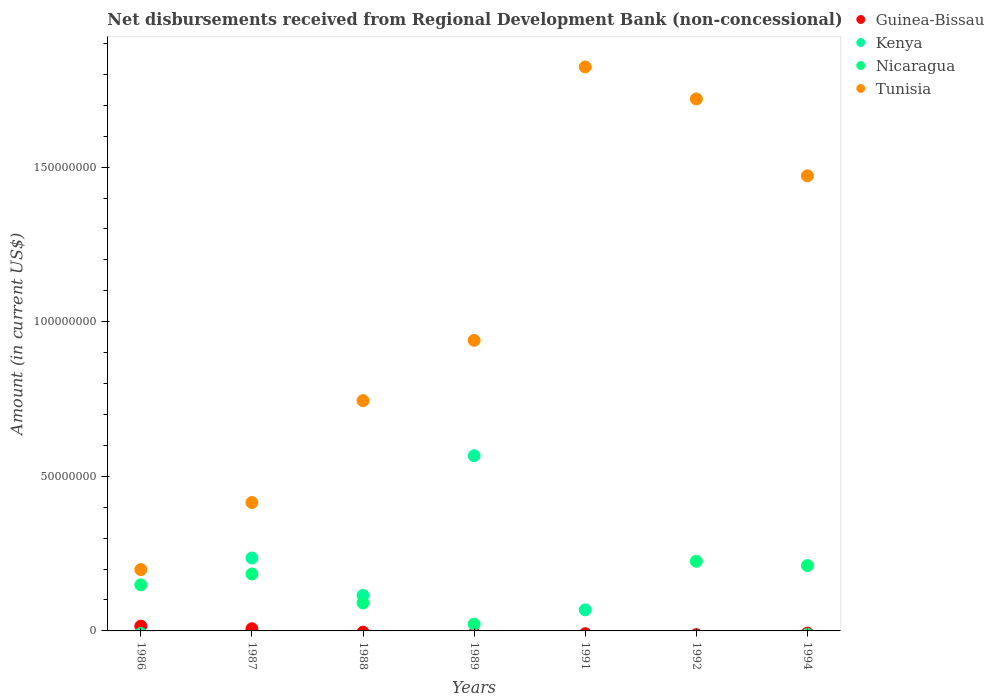What is the amount of disbursements received from Regional Development Bank in Kenya in 1992?
Provide a succinct answer. 0. Across all years, what is the maximum amount of disbursements received from Regional Development Bank in Nicaragua?
Keep it short and to the point. 2.25e+07. In which year was the amount of disbursements received from Regional Development Bank in Guinea-Bissau maximum?
Give a very brief answer. 1986. What is the total amount of disbursements received from Regional Development Bank in Kenya in the graph?
Ensure brevity in your answer.  9.85e+07. What is the difference between the amount of disbursements received from Regional Development Bank in Tunisia in 1989 and that in 1992?
Keep it short and to the point. -7.81e+07. What is the difference between the amount of disbursements received from Regional Development Bank in Guinea-Bissau in 1991 and the amount of disbursements received from Regional Development Bank in Nicaragua in 1992?
Your answer should be compact. -2.25e+07. What is the average amount of disbursements received from Regional Development Bank in Tunisia per year?
Your response must be concise. 1.04e+08. In the year 1987, what is the difference between the amount of disbursements received from Regional Development Bank in Tunisia and amount of disbursements received from Regional Development Bank in Nicaragua?
Your answer should be compact. 2.31e+07. What is the ratio of the amount of disbursements received from Regional Development Bank in Nicaragua in 1989 to that in 1992?
Make the answer very short. 0.1. Is the amount of disbursements received from Regional Development Bank in Tunisia in 1986 less than that in 1992?
Give a very brief answer. Yes. Is the difference between the amount of disbursements received from Regional Development Bank in Tunisia in 1986 and 1989 greater than the difference between the amount of disbursements received from Regional Development Bank in Nicaragua in 1986 and 1989?
Give a very brief answer. No. What is the difference between the highest and the second highest amount of disbursements received from Regional Development Bank in Kenya?
Your answer should be very brief. 3.31e+07. What is the difference between the highest and the lowest amount of disbursements received from Regional Development Bank in Nicaragua?
Offer a very short reply. 2.25e+07. In how many years, is the amount of disbursements received from Regional Development Bank in Tunisia greater than the average amount of disbursements received from Regional Development Bank in Tunisia taken over all years?
Keep it short and to the point. 3. Is the sum of the amount of disbursements received from Regional Development Bank in Tunisia in 1991 and 1992 greater than the maximum amount of disbursements received from Regional Development Bank in Guinea-Bissau across all years?
Give a very brief answer. Yes. Is it the case that in every year, the sum of the amount of disbursements received from Regional Development Bank in Guinea-Bissau and amount of disbursements received from Regional Development Bank in Nicaragua  is greater than the sum of amount of disbursements received from Regional Development Bank in Kenya and amount of disbursements received from Regional Development Bank in Tunisia?
Ensure brevity in your answer.  No. Is the amount of disbursements received from Regional Development Bank in Kenya strictly greater than the amount of disbursements received from Regional Development Bank in Guinea-Bissau over the years?
Offer a terse response. No. Is the amount of disbursements received from Regional Development Bank in Nicaragua strictly less than the amount of disbursements received from Regional Development Bank in Guinea-Bissau over the years?
Provide a short and direct response. No. What is the difference between two consecutive major ticks on the Y-axis?
Your answer should be very brief. 5.00e+07. Are the values on the major ticks of Y-axis written in scientific E-notation?
Make the answer very short. No. Does the graph contain any zero values?
Your answer should be compact. Yes. Does the graph contain grids?
Your response must be concise. No. What is the title of the graph?
Keep it short and to the point. Net disbursements received from Regional Development Bank (non-concessional). What is the label or title of the X-axis?
Give a very brief answer. Years. What is the Amount (in current US$) of Guinea-Bissau in 1986?
Provide a succinct answer. 1.56e+06. What is the Amount (in current US$) in Nicaragua in 1986?
Keep it short and to the point. 1.49e+07. What is the Amount (in current US$) of Tunisia in 1986?
Make the answer very short. 1.98e+07. What is the Amount (in current US$) in Guinea-Bissau in 1987?
Your answer should be compact. 7.05e+05. What is the Amount (in current US$) of Kenya in 1987?
Your answer should be compact. 2.36e+07. What is the Amount (in current US$) of Nicaragua in 1987?
Your response must be concise. 1.84e+07. What is the Amount (in current US$) in Tunisia in 1987?
Give a very brief answer. 4.15e+07. What is the Amount (in current US$) in Guinea-Bissau in 1988?
Offer a very short reply. 0. What is the Amount (in current US$) in Kenya in 1988?
Your answer should be very brief. 1.15e+07. What is the Amount (in current US$) in Nicaragua in 1988?
Offer a very short reply. 9.03e+06. What is the Amount (in current US$) of Tunisia in 1988?
Provide a succinct answer. 7.45e+07. What is the Amount (in current US$) of Guinea-Bissau in 1989?
Your answer should be compact. 0. What is the Amount (in current US$) in Kenya in 1989?
Your answer should be compact. 5.67e+07. What is the Amount (in current US$) of Nicaragua in 1989?
Make the answer very short. 2.19e+06. What is the Amount (in current US$) in Tunisia in 1989?
Ensure brevity in your answer.  9.40e+07. What is the Amount (in current US$) in Kenya in 1991?
Your answer should be very brief. 6.82e+06. What is the Amount (in current US$) of Tunisia in 1991?
Your answer should be very brief. 1.82e+08. What is the Amount (in current US$) of Guinea-Bissau in 1992?
Provide a succinct answer. 0. What is the Amount (in current US$) of Kenya in 1992?
Ensure brevity in your answer.  0. What is the Amount (in current US$) of Nicaragua in 1992?
Your response must be concise. 2.25e+07. What is the Amount (in current US$) of Tunisia in 1992?
Your answer should be compact. 1.72e+08. What is the Amount (in current US$) in Guinea-Bissau in 1994?
Your answer should be compact. 0. What is the Amount (in current US$) in Kenya in 1994?
Ensure brevity in your answer.  0. What is the Amount (in current US$) in Nicaragua in 1994?
Your response must be concise. 2.11e+07. What is the Amount (in current US$) in Tunisia in 1994?
Offer a terse response. 1.47e+08. Across all years, what is the maximum Amount (in current US$) in Guinea-Bissau?
Your response must be concise. 1.56e+06. Across all years, what is the maximum Amount (in current US$) in Kenya?
Your answer should be compact. 5.67e+07. Across all years, what is the maximum Amount (in current US$) in Nicaragua?
Keep it short and to the point. 2.25e+07. Across all years, what is the maximum Amount (in current US$) of Tunisia?
Your response must be concise. 1.82e+08. Across all years, what is the minimum Amount (in current US$) in Guinea-Bissau?
Give a very brief answer. 0. Across all years, what is the minimum Amount (in current US$) in Tunisia?
Your response must be concise. 1.98e+07. What is the total Amount (in current US$) in Guinea-Bissau in the graph?
Provide a succinct answer. 2.27e+06. What is the total Amount (in current US$) of Kenya in the graph?
Keep it short and to the point. 9.85e+07. What is the total Amount (in current US$) of Nicaragua in the graph?
Provide a short and direct response. 8.82e+07. What is the total Amount (in current US$) in Tunisia in the graph?
Provide a succinct answer. 7.31e+08. What is the difference between the Amount (in current US$) in Guinea-Bissau in 1986 and that in 1987?
Ensure brevity in your answer.  8.56e+05. What is the difference between the Amount (in current US$) of Nicaragua in 1986 and that in 1987?
Provide a short and direct response. -3.50e+06. What is the difference between the Amount (in current US$) in Tunisia in 1986 and that in 1987?
Offer a very short reply. -2.17e+07. What is the difference between the Amount (in current US$) in Nicaragua in 1986 and that in 1988?
Provide a short and direct response. 5.87e+06. What is the difference between the Amount (in current US$) in Tunisia in 1986 and that in 1988?
Keep it short and to the point. -5.46e+07. What is the difference between the Amount (in current US$) in Nicaragua in 1986 and that in 1989?
Your answer should be very brief. 1.27e+07. What is the difference between the Amount (in current US$) in Tunisia in 1986 and that in 1989?
Provide a short and direct response. -7.41e+07. What is the difference between the Amount (in current US$) in Tunisia in 1986 and that in 1991?
Give a very brief answer. -1.63e+08. What is the difference between the Amount (in current US$) of Nicaragua in 1986 and that in 1992?
Offer a very short reply. -7.62e+06. What is the difference between the Amount (in current US$) of Tunisia in 1986 and that in 1992?
Give a very brief answer. -1.52e+08. What is the difference between the Amount (in current US$) in Nicaragua in 1986 and that in 1994?
Provide a succinct answer. -6.22e+06. What is the difference between the Amount (in current US$) of Tunisia in 1986 and that in 1994?
Offer a terse response. -1.27e+08. What is the difference between the Amount (in current US$) of Kenya in 1987 and that in 1988?
Provide a succinct answer. 1.21e+07. What is the difference between the Amount (in current US$) in Nicaragua in 1987 and that in 1988?
Provide a succinct answer. 9.37e+06. What is the difference between the Amount (in current US$) in Tunisia in 1987 and that in 1988?
Keep it short and to the point. -3.29e+07. What is the difference between the Amount (in current US$) of Kenya in 1987 and that in 1989?
Provide a succinct answer. -3.31e+07. What is the difference between the Amount (in current US$) in Nicaragua in 1987 and that in 1989?
Offer a very short reply. 1.62e+07. What is the difference between the Amount (in current US$) in Tunisia in 1987 and that in 1989?
Offer a very short reply. -5.24e+07. What is the difference between the Amount (in current US$) in Kenya in 1987 and that in 1991?
Provide a short and direct response. 1.68e+07. What is the difference between the Amount (in current US$) in Tunisia in 1987 and that in 1991?
Ensure brevity in your answer.  -1.41e+08. What is the difference between the Amount (in current US$) of Nicaragua in 1987 and that in 1992?
Offer a terse response. -4.11e+06. What is the difference between the Amount (in current US$) of Tunisia in 1987 and that in 1992?
Make the answer very short. -1.31e+08. What is the difference between the Amount (in current US$) in Nicaragua in 1987 and that in 1994?
Your answer should be compact. -2.72e+06. What is the difference between the Amount (in current US$) of Tunisia in 1987 and that in 1994?
Your answer should be compact. -1.06e+08. What is the difference between the Amount (in current US$) of Kenya in 1988 and that in 1989?
Provide a succinct answer. -4.52e+07. What is the difference between the Amount (in current US$) in Nicaragua in 1988 and that in 1989?
Your response must be concise. 6.84e+06. What is the difference between the Amount (in current US$) in Tunisia in 1988 and that in 1989?
Provide a succinct answer. -1.95e+07. What is the difference between the Amount (in current US$) of Kenya in 1988 and that in 1991?
Provide a succinct answer. 4.66e+06. What is the difference between the Amount (in current US$) in Tunisia in 1988 and that in 1991?
Your answer should be compact. -1.08e+08. What is the difference between the Amount (in current US$) of Nicaragua in 1988 and that in 1992?
Your answer should be compact. -1.35e+07. What is the difference between the Amount (in current US$) in Tunisia in 1988 and that in 1992?
Make the answer very short. -9.76e+07. What is the difference between the Amount (in current US$) of Nicaragua in 1988 and that in 1994?
Make the answer very short. -1.21e+07. What is the difference between the Amount (in current US$) in Tunisia in 1988 and that in 1994?
Offer a very short reply. -7.27e+07. What is the difference between the Amount (in current US$) in Kenya in 1989 and that in 1991?
Your answer should be compact. 4.98e+07. What is the difference between the Amount (in current US$) in Tunisia in 1989 and that in 1991?
Keep it short and to the point. -8.84e+07. What is the difference between the Amount (in current US$) of Nicaragua in 1989 and that in 1992?
Offer a very short reply. -2.03e+07. What is the difference between the Amount (in current US$) of Tunisia in 1989 and that in 1992?
Your answer should be very brief. -7.81e+07. What is the difference between the Amount (in current US$) in Nicaragua in 1989 and that in 1994?
Ensure brevity in your answer.  -1.89e+07. What is the difference between the Amount (in current US$) of Tunisia in 1989 and that in 1994?
Your answer should be very brief. -5.32e+07. What is the difference between the Amount (in current US$) of Tunisia in 1991 and that in 1992?
Offer a terse response. 1.03e+07. What is the difference between the Amount (in current US$) of Tunisia in 1991 and that in 1994?
Provide a succinct answer. 3.52e+07. What is the difference between the Amount (in current US$) in Nicaragua in 1992 and that in 1994?
Offer a terse response. 1.40e+06. What is the difference between the Amount (in current US$) in Tunisia in 1992 and that in 1994?
Your answer should be very brief. 2.49e+07. What is the difference between the Amount (in current US$) in Guinea-Bissau in 1986 and the Amount (in current US$) in Kenya in 1987?
Ensure brevity in your answer.  -2.20e+07. What is the difference between the Amount (in current US$) in Guinea-Bissau in 1986 and the Amount (in current US$) in Nicaragua in 1987?
Give a very brief answer. -1.68e+07. What is the difference between the Amount (in current US$) of Guinea-Bissau in 1986 and the Amount (in current US$) of Tunisia in 1987?
Make the answer very short. -4.00e+07. What is the difference between the Amount (in current US$) in Nicaragua in 1986 and the Amount (in current US$) in Tunisia in 1987?
Your answer should be very brief. -2.66e+07. What is the difference between the Amount (in current US$) in Guinea-Bissau in 1986 and the Amount (in current US$) in Kenya in 1988?
Provide a succinct answer. -9.92e+06. What is the difference between the Amount (in current US$) of Guinea-Bissau in 1986 and the Amount (in current US$) of Nicaragua in 1988?
Offer a very short reply. -7.47e+06. What is the difference between the Amount (in current US$) of Guinea-Bissau in 1986 and the Amount (in current US$) of Tunisia in 1988?
Give a very brief answer. -7.29e+07. What is the difference between the Amount (in current US$) of Nicaragua in 1986 and the Amount (in current US$) of Tunisia in 1988?
Offer a terse response. -5.96e+07. What is the difference between the Amount (in current US$) in Guinea-Bissau in 1986 and the Amount (in current US$) in Kenya in 1989?
Provide a succinct answer. -5.51e+07. What is the difference between the Amount (in current US$) of Guinea-Bissau in 1986 and the Amount (in current US$) of Nicaragua in 1989?
Keep it short and to the point. -6.28e+05. What is the difference between the Amount (in current US$) in Guinea-Bissau in 1986 and the Amount (in current US$) in Tunisia in 1989?
Make the answer very short. -9.24e+07. What is the difference between the Amount (in current US$) in Nicaragua in 1986 and the Amount (in current US$) in Tunisia in 1989?
Make the answer very short. -7.91e+07. What is the difference between the Amount (in current US$) in Guinea-Bissau in 1986 and the Amount (in current US$) in Kenya in 1991?
Offer a terse response. -5.26e+06. What is the difference between the Amount (in current US$) in Guinea-Bissau in 1986 and the Amount (in current US$) in Tunisia in 1991?
Offer a very short reply. -1.81e+08. What is the difference between the Amount (in current US$) of Nicaragua in 1986 and the Amount (in current US$) of Tunisia in 1991?
Your answer should be compact. -1.67e+08. What is the difference between the Amount (in current US$) in Guinea-Bissau in 1986 and the Amount (in current US$) in Nicaragua in 1992?
Offer a terse response. -2.10e+07. What is the difference between the Amount (in current US$) in Guinea-Bissau in 1986 and the Amount (in current US$) in Tunisia in 1992?
Provide a short and direct response. -1.70e+08. What is the difference between the Amount (in current US$) in Nicaragua in 1986 and the Amount (in current US$) in Tunisia in 1992?
Offer a very short reply. -1.57e+08. What is the difference between the Amount (in current US$) of Guinea-Bissau in 1986 and the Amount (in current US$) of Nicaragua in 1994?
Provide a short and direct response. -1.96e+07. What is the difference between the Amount (in current US$) of Guinea-Bissau in 1986 and the Amount (in current US$) of Tunisia in 1994?
Your answer should be compact. -1.46e+08. What is the difference between the Amount (in current US$) in Nicaragua in 1986 and the Amount (in current US$) in Tunisia in 1994?
Offer a very short reply. -1.32e+08. What is the difference between the Amount (in current US$) in Guinea-Bissau in 1987 and the Amount (in current US$) in Kenya in 1988?
Your answer should be compact. -1.08e+07. What is the difference between the Amount (in current US$) in Guinea-Bissau in 1987 and the Amount (in current US$) in Nicaragua in 1988?
Offer a very short reply. -8.33e+06. What is the difference between the Amount (in current US$) in Guinea-Bissau in 1987 and the Amount (in current US$) in Tunisia in 1988?
Offer a terse response. -7.38e+07. What is the difference between the Amount (in current US$) of Kenya in 1987 and the Amount (in current US$) of Nicaragua in 1988?
Offer a very short reply. 1.45e+07. What is the difference between the Amount (in current US$) of Kenya in 1987 and the Amount (in current US$) of Tunisia in 1988?
Ensure brevity in your answer.  -5.09e+07. What is the difference between the Amount (in current US$) in Nicaragua in 1987 and the Amount (in current US$) in Tunisia in 1988?
Offer a terse response. -5.61e+07. What is the difference between the Amount (in current US$) of Guinea-Bissau in 1987 and the Amount (in current US$) of Kenya in 1989?
Your answer should be very brief. -5.59e+07. What is the difference between the Amount (in current US$) of Guinea-Bissau in 1987 and the Amount (in current US$) of Nicaragua in 1989?
Your answer should be very brief. -1.48e+06. What is the difference between the Amount (in current US$) of Guinea-Bissau in 1987 and the Amount (in current US$) of Tunisia in 1989?
Provide a succinct answer. -9.33e+07. What is the difference between the Amount (in current US$) of Kenya in 1987 and the Amount (in current US$) of Nicaragua in 1989?
Your response must be concise. 2.14e+07. What is the difference between the Amount (in current US$) of Kenya in 1987 and the Amount (in current US$) of Tunisia in 1989?
Your response must be concise. -7.04e+07. What is the difference between the Amount (in current US$) of Nicaragua in 1987 and the Amount (in current US$) of Tunisia in 1989?
Your answer should be very brief. -7.56e+07. What is the difference between the Amount (in current US$) of Guinea-Bissau in 1987 and the Amount (in current US$) of Kenya in 1991?
Keep it short and to the point. -6.12e+06. What is the difference between the Amount (in current US$) in Guinea-Bissau in 1987 and the Amount (in current US$) in Tunisia in 1991?
Your response must be concise. -1.82e+08. What is the difference between the Amount (in current US$) of Kenya in 1987 and the Amount (in current US$) of Tunisia in 1991?
Provide a succinct answer. -1.59e+08. What is the difference between the Amount (in current US$) of Nicaragua in 1987 and the Amount (in current US$) of Tunisia in 1991?
Make the answer very short. -1.64e+08. What is the difference between the Amount (in current US$) in Guinea-Bissau in 1987 and the Amount (in current US$) in Nicaragua in 1992?
Provide a succinct answer. -2.18e+07. What is the difference between the Amount (in current US$) of Guinea-Bissau in 1987 and the Amount (in current US$) of Tunisia in 1992?
Provide a succinct answer. -1.71e+08. What is the difference between the Amount (in current US$) in Kenya in 1987 and the Amount (in current US$) in Nicaragua in 1992?
Give a very brief answer. 1.06e+06. What is the difference between the Amount (in current US$) in Kenya in 1987 and the Amount (in current US$) in Tunisia in 1992?
Your answer should be very brief. -1.48e+08. What is the difference between the Amount (in current US$) of Nicaragua in 1987 and the Amount (in current US$) of Tunisia in 1992?
Your answer should be compact. -1.54e+08. What is the difference between the Amount (in current US$) in Guinea-Bissau in 1987 and the Amount (in current US$) in Nicaragua in 1994?
Make the answer very short. -2.04e+07. What is the difference between the Amount (in current US$) of Guinea-Bissau in 1987 and the Amount (in current US$) of Tunisia in 1994?
Your answer should be very brief. -1.46e+08. What is the difference between the Amount (in current US$) in Kenya in 1987 and the Amount (in current US$) in Nicaragua in 1994?
Your response must be concise. 2.46e+06. What is the difference between the Amount (in current US$) of Kenya in 1987 and the Amount (in current US$) of Tunisia in 1994?
Provide a succinct answer. -1.24e+08. What is the difference between the Amount (in current US$) of Nicaragua in 1987 and the Amount (in current US$) of Tunisia in 1994?
Ensure brevity in your answer.  -1.29e+08. What is the difference between the Amount (in current US$) of Kenya in 1988 and the Amount (in current US$) of Nicaragua in 1989?
Ensure brevity in your answer.  9.29e+06. What is the difference between the Amount (in current US$) of Kenya in 1988 and the Amount (in current US$) of Tunisia in 1989?
Ensure brevity in your answer.  -8.25e+07. What is the difference between the Amount (in current US$) in Nicaragua in 1988 and the Amount (in current US$) in Tunisia in 1989?
Keep it short and to the point. -8.49e+07. What is the difference between the Amount (in current US$) of Kenya in 1988 and the Amount (in current US$) of Tunisia in 1991?
Your answer should be compact. -1.71e+08. What is the difference between the Amount (in current US$) in Nicaragua in 1988 and the Amount (in current US$) in Tunisia in 1991?
Offer a very short reply. -1.73e+08. What is the difference between the Amount (in current US$) of Kenya in 1988 and the Amount (in current US$) of Nicaragua in 1992?
Make the answer very short. -1.10e+07. What is the difference between the Amount (in current US$) in Kenya in 1988 and the Amount (in current US$) in Tunisia in 1992?
Offer a terse response. -1.61e+08. What is the difference between the Amount (in current US$) in Nicaragua in 1988 and the Amount (in current US$) in Tunisia in 1992?
Give a very brief answer. -1.63e+08. What is the difference between the Amount (in current US$) in Kenya in 1988 and the Amount (in current US$) in Nicaragua in 1994?
Offer a terse response. -9.64e+06. What is the difference between the Amount (in current US$) in Kenya in 1988 and the Amount (in current US$) in Tunisia in 1994?
Provide a succinct answer. -1.36e+08. What is the difference between the Amount (in current US$) in Nicaragua in 1988 and the Amount (in current US$) in Tunisia in 1994?
Offer a very short reply. -1.38e+08. What is the difference between the Amount (in current US$) of Kenya in 1989 and the Amount (in current US$) of Tunisia in 1991?
Your answer should be compact. -1.26e+08. What is the difference between the Amount (in current US$) in Nicaragua in 1989 and the Amount (in current US$) in Tunisia in 1991?
Offer a terse response. -1.80e+08. What is the difference between the Amount (in current US$) of Kenya in 1989 and the Amount (in current US$) of Nicaragua in 1992?
Provide a short and direct response. 3.41e+07. What is the difference between the Amount (in current US$) of Kenya in 1989 and the Amount (in current US$) of Tunisia in 1992?
Your response must be concise. -1.15e+08. What is the difference between the Amount (in current US$) in Nicaragua in 1989 and the Amount (in current US$) in Tunisia in 1992?
Give a very brief answer. -1.70e+08. What is the difference between the Amount (in current US$) in Kenya in 1989 and the Amount (in current US$) in Nicaragua in 1994?
Your response must be concise. 3.55e+07. What is the difference between the Amount (in current US$) in Kenya in 1989 and the Amount (in current US$) in Tunisia in 1994?
Offer a very short reply. -9.05e+07. What is the difference between the Amount (in current US$) in Nicaragua in 1989 and the Amount (in current US$) in Tunisia in 1994?
Keep it short and to the point. -1.45e+08. What is the difference between the Amount (in current US$) of Kenya in 1991 and the Amount (in current US$) of Nicaragua in 1992?
Keep it short and to the point. -1.57e+07. What is the difference between the Amount (in current US$) in Kenya in 1991 and the Amount (in current US$) in Tunisia in 1992?
Keep it short and to the point. -1.65e+08. What is the difference between the Amount (in current US$) in Kenya in 1991 and the Amount (in current US$) in Nicaragua in 1994?
Ensure brevity in your answer.  -1.43e+07. What is the difference between the Amount (in current US$) of Kenya in 1991 and the Amount (in current US$) of Tunisia in 1994?
Provide a short and direct response. -1.40e+08. What is the difference between the Amount (in current US$) in Nicaragua in 1992 and the Amount (in current US$) in Tunisia in 1994?
Your answer should be compact. -1.25e+08. What is the average Amount (in current US$) in Guinea-Bissau per year?
Your response must be concise. 3.24e+05. What is the average Amount (in current US$) in Kenya per year?
Your answer should be compact. 1.41e+07. What is the average Amount (in current US$) in Nicaragua per year?
Provide a succinct answer. 1.26e+07. What is the average Amount (in current US$) of Tunisia per year?
Offer a terse response. 1.04e+08. In the year 1986, what is the difference between the Amount (in current US$) in Guinea-Bissau and Amount (in current US$) in Nicaragua?
Give a very brief answer. -1.33e+07. In the year 1986, what is the difference between the Amount (in current US$) in Guinea-Bissau and Amount (in current US$) in Tunisia?
Make the answer very short. -1.83e+07. In the year 1986, what is the difference between the Amount (in current US$) in Nicaragua and Amount (in current US$) in Tunisia?
Offer a terse response. -4.94e+06. In the year 1987, what is the difference between the Amount (in current US$) in Guinea-Bissau and Amount (in current US$) in Kenya?
Make the answer very short. -2.29e+07. In the year 1987, what is the difference between the Amount (in current US$) of Guinea-Bissau and Amount (in current US$) of Nicaragua?
Provide a short and direct response. -1.77e+07. In the year 1987, what is the difference between the Amount (in current US$) of Guinea-Bissau and Amount (in current US$) of Tunisia?
Offer a terse response. -4.08e+07. In the year 1987, what is the difference between the Amount (in current US$) in Kenya and Amount (in current US$) in Nicaragua?
Your answer should be very brief. 5.18e+06. In the year 1987, what is the difference between the Amount (in current US$) in Kenya and Amount (in current US$) in Tunisia?
Keep it short and to the point. -1.79e+07. In the year 1987, what is the difference between the Amount (in current US$) of Nicaragua and Amount (in current US$) of Tunisia?
Provide a short and direct response. -2.31e+07. In the year 1988, what is the difference between the Amount (in current US$) of Kenya and Amount (in current US$) of Nicaragua?
Your response must be concise. 2.45e+06. In the year 1988, what is the difference between the Amount (in current US$) in Kenya and Amount (in current US$) in Tunisia?
Offer a terse response. -6.30e+07. In the year 1988, what is the difference between the Amount (in current US$) in Nicaragua and Amount (in current US$) in Tunisia?
Provide a succinct answer. -6.54e+07. In the year 1989, what is the difference between the Amount (in current US$) of Kenya and Amount (in current US$) of Nicaragua?
Offer a very short reply. 5.45e+07. In the year 1989, what is the difference between the Amount (in current US$) in Kenya and Amount (in current US$) in Tunisia?
Give a very brief answer. -3.73e+07. In the year 1989, what is the difference between the Amount (in current US$) in Nicaragua and Amount (in current US$) in Tunisia?
Give a very brief answer. -9.18e+07. In the year 1991, what is the difference between the Amount (in current US$) of Kenya and Amount (in current US$) of Tunisia?
Your response must be concise. -1.76e+08. In the year 1992, what is the difference between the Amount (in current US$) in Nicaragua and Amount (in current US$) in Tunisia?
Provide a short and direct response. -1.50e+08. In the year 1994, what is the difference between the Amount (in current US$) in Nicaragua and Amount (in current US$) in Tunisia?
Ensure brevity in your answer.  -1.26e+08. What is the ratio of the Amount (in current US$) in Guinea-Bissau in 1986 to that in 1987?
Your answer should be compact. 2.21. What is the ratio of the Amount (in current US$) in Nicaragua in 1986 to that in 1987?
Provide a succinct answer. 0.81. What is the ratio of the Amount (in current US$) in Tunisia in 1986 to that in 1987?
Your response must be concise. 0.48. What is the ratio of the Amount (in current US$) in Nicaragua in 1986 to that in 1988?
Keep it short and to the point. 1.65. What is the ratio of the Amount (in current US$) in Tunisia in 1986 to that in 1988?
Offer a very short reply. 0.27. What is the ratio of the Amount (in current US$) of Nicaragua in 1986 to that in 1989?
Provide a succinct answer. 6.81. What is the ratio of the Amount (in current US$) of Tunisia in 1986 to that in 1989?
Keep it short and to the point. 0.21. What is the ratio of the Amount (in current US$) in Tunisia in 1986 to that in 1991?
Keep it short and to the point. 0.11. What is the ratio of the Amount (in current US$) of Nicaragua in 1986 to that in 1992?
Keep it short and to the point. 0.66. What is the ratio of the Amount (in current US$) of Tunisia in 1986 to that in 1992?
Keep it short and to the point. 0.12. What is the ratio of the Amount (in current US$) in Nicaragua in 1986 to that in 1994?
Offer a terse response. 0.71. What is the ratio of the Amount (in current US$) in Tunisia in 1986 to that in 1994?
Offer a very short reply. 0.13. What is the ratio of the Amount (in current US$) of Kenya in 1987 to that in 1988?
Offer a terse response. 2.05. What is the ratio of the Amount (in current US$) of Nicaragua in 1987 to that in 1988?
Your answer should be very brief. 2.04. What is the ratio of the Amount (in current US$) of Tunisia in 1987 to that in 1988?
Keep it short and to the point. 0.56. What is the ratio of the Amount (in current US$) of Kenya in 1987 to that in 1989?
Offer a very short reply. 0.42. What is the ratio of the Amount (in current US$) of Nicaragua in 1987 to that in 1989?
Keep it short and to the point. 8.41. What is the ratio of the Amount (in current US$) in Tunisia in 1987 to that in 1989?
Your answer should be very brief. 0.44. What is the ratio of the Amount (in current US$) in Kenya in 1987 to that in 1991?
Offer a very short reply. 3.46. What is the ratio of the Amount (in current US$) in Tunisia in 1987 to that in 1991?
Provide a succinct answer. 0.23. What is the ratio of the Amount (in current US$) in Nicaragua in 1987 to that in 1992?
Your answer should be very brief. 0.82. What is the ratio of the Amount (in current US$) in Tunisia in 1987 to that in 1992?
Offer a very short reply. 0.24. What is the ratio of the Amount (in current US$) of Nicaragua in 1987 to that in 1994?
Provide a succinct answer. 0.87. What is the ratio of the Amount (in current US$) of Tunisia in 1987 to that in 1994?
Provide a short and direct response. 0.28. What is the ratio of the Amount (in current US$) of Kenya in 1988 to that in 1989?
Your answer should be compact. 0.2. What is the ratio of the Amount (in current US$) in Nicaragua in 1988 to that in 1989?
Your answer should be very brief. 4.13. What is the ratio of the Amount (in current US$) in Tunisia in 1988 to that in 1989?
Ensure brevity in your answer.  0.79. What is the ratio of the Amount (in current US$) of Kenya in 1988 to that in 1991?
Your response must be concise. 1.68. What is the ratio of the Amount (in current US$) of Tunisia in 1988 to that in 1991?
Your response must be concise. 0.41. What is the ratio of the Amount (in current US$) of Nicaragua in 1988 to that in 1992?
Provide a short and direct response. 0.4. What is the ratio of the Amount (in current US$) in Tunisia in 1988 to that in 1992?
Provide a short and direct response. 0.43. What is the ratio of the Amount (in current US$) in Nicaragua in 1988 to that in 1994?
Offer a terse response. 0.43. What is the ratio of the Amount (in current US$) of Tunisia in 1988 to that in 1994?
Your answer should be compact. 0.51. What is the ratio of the Amount (in current US$) of Kenya in 1989 to that in 1991?
Provide a succinct answer. 8.3. What is the ratio of the Amount (in current US$) of Tunisia in 1989 to that in 1991?
Provide a short and direct response. 0.52. What is the ratio of the Amount (in current US$) of Nicaragua in 1989 to that in 1992?
Offer a terse response. 0.1. What is the ratio of the Amount (in current US$) of Tunisia in 1989 to that in 1992?
Keep it short and to the point. 0.55. What is the ratio of the Amount (in current US$) in Nicaragua in 1989 to that in 1994?
Your answer should be very brief. 0.1. What is the ratio of the Amount (in current US$) of Tunisia in 1989 to that in 1994?
Offer a terse response. 0.64. What is the ratio of the Amount (in current US$) of Tunisia in 1991 to that in 1992?
Your answer should be compact. 1.06. What is the ratio of the Amount (in current US$) in Tunisia in 1991 to that in 1994?
Provide a succinct answer. 1.24. What is the ratio of the Amount (in current US$) in Nicaragua in 1992 to that in 1994?
Offer a terse response. 1.07. What is the ratio of the Amount (in current US$) in Tunisia in 1992 to that in 1994?
Your answer should be very brief. 1.17. What is the difference between the highest and the second highest Amount (in current US$) in Kenya?
Give a very brief answer. 3.31e+07. What is the difference between the highest and the second highest Amount (in current US$) in Nicaragua?
Your answer should be very brief. 1.40e+06. What is the difference between the highest and the second highest Amount (in current US$) of Tunisia?
Keep it short and to the point. 1.03e+07. What is the difference between the highest and the lowest Amount (in current US$) in Guinea-Bissau?
Your answer should be very brief. 1.56e+06. What is the difference between the highest and the lowest Amount (in current US$) of Kenya?
Offer a very short reply. 5.67e+07. What is the difference between the highest and the lowest Amount (in current US$) of Nicaragua?
Provide a short and direct response. 2.25e+07. What is the difference between the highest and the lowest Amount (in current US$) in Tunisia?
Offer a very short reply. 1.63e+08. 